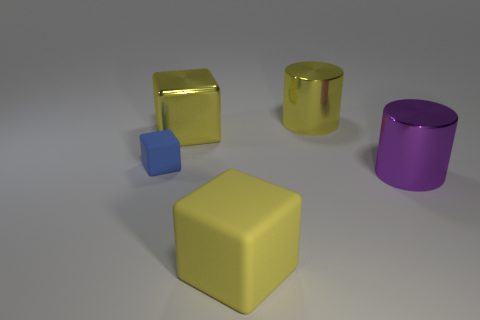Are there an equal number of shiny things in front of the purple cylinder and big gray matte blocks?
Offer a very short reply. Yes. Are there any other things that are the same size as the blue matte cube?
Keep it short and to the point. No. What is the material of the blue cube behind the large yellow object that is in front of the tiny blue object?
Keep it short and to the point. Rubber. What shape is the big shiny object that is both right of the big rubber thing and behind the purple metal cylinder?
Provide a succinct answer. Cylinder. What size is the other rubber object that is the same shape as the large rubber thing?
Keep it short and to the point. Small. Is the number of purple shiny cylinders behind the large yellow metallic cylinder less than the number of big purple shiny objects?
Keep it short and to the point. Yes. There is a cylinder that is right of the big yellow metallic cylinder; what is its size?
Provide a short and direct response. Large. There is another object that is the same shape as the purple object; what color is it?
Your answer should be compact. Yellow. What number of big objects have the same color as the shiny cube?
Offer a very short reply. 2. There is a big yellow shiny thing that is to the right of the block right of the yellow metal block; are there any shiny things that are in front of it?
Offer a terse response. Yes. 